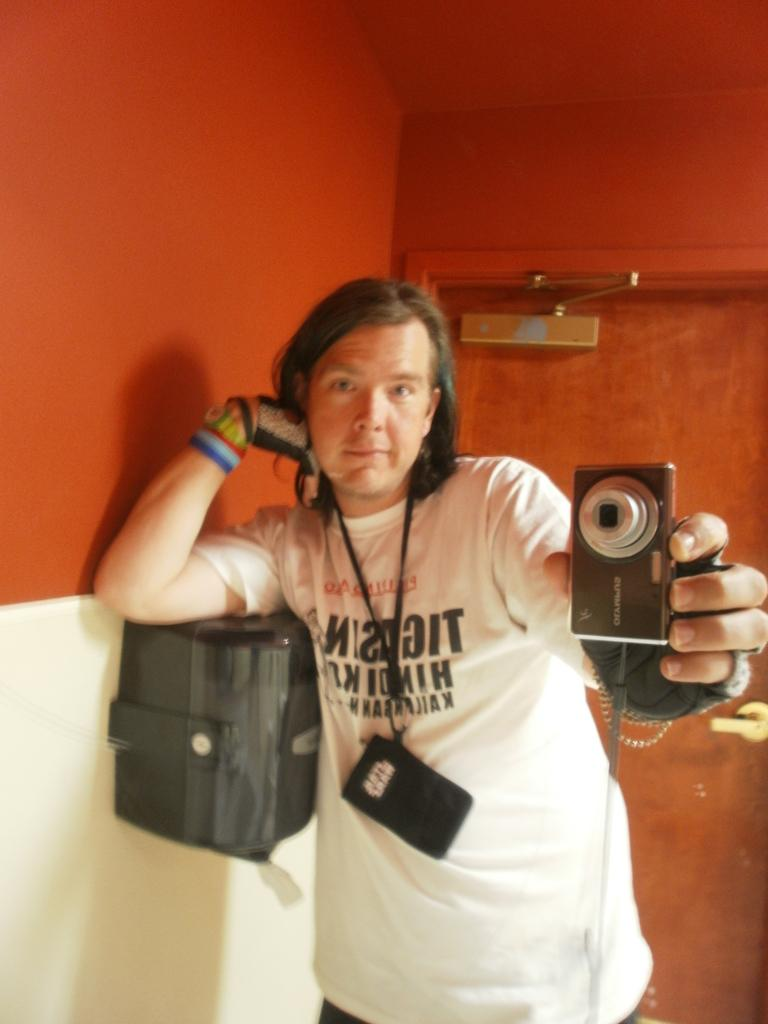What is the person in the image doing? The person is holding a camera in one hand and has his other hand on a black box. What might the person be doing with the camera? The person might be taking a picture or recording something. What is the background of the image? The person is standing in front of a red wall. Who is the person looking at? The person is looking at someone, but we cannot see the other person in the image. What type of property does the person feel ashamed of in the image? There is no indication of shame or property in the image; the person is simply holding a camera and looking at someone. 